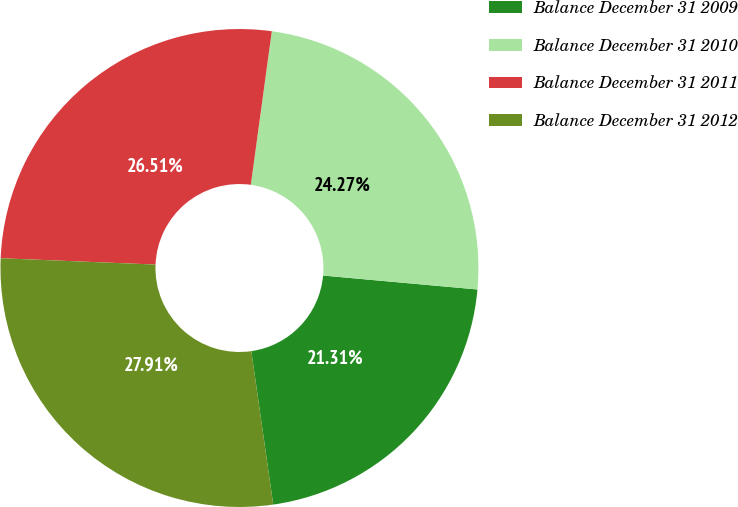<chart> <loc_0><loc_0><loc_500><loc_500><pie_chart><fcel>Balance December 31 2009<fcel>Balance December 31 2010<fcel>Balance December 31 2011<fcel>Balance December 31 2012<nl><fcel>21.31%<fcel>24.27%<fcel>26.51%<fcel>27.91%<nl></chart> 